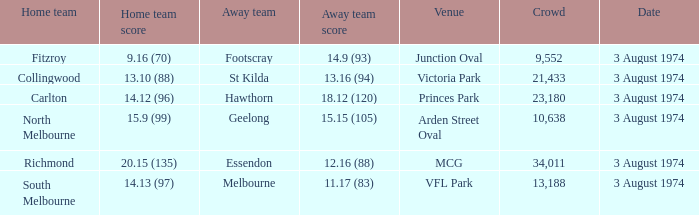Which Venue has a Home team score of 9.16 (70)? Junction Oval. 